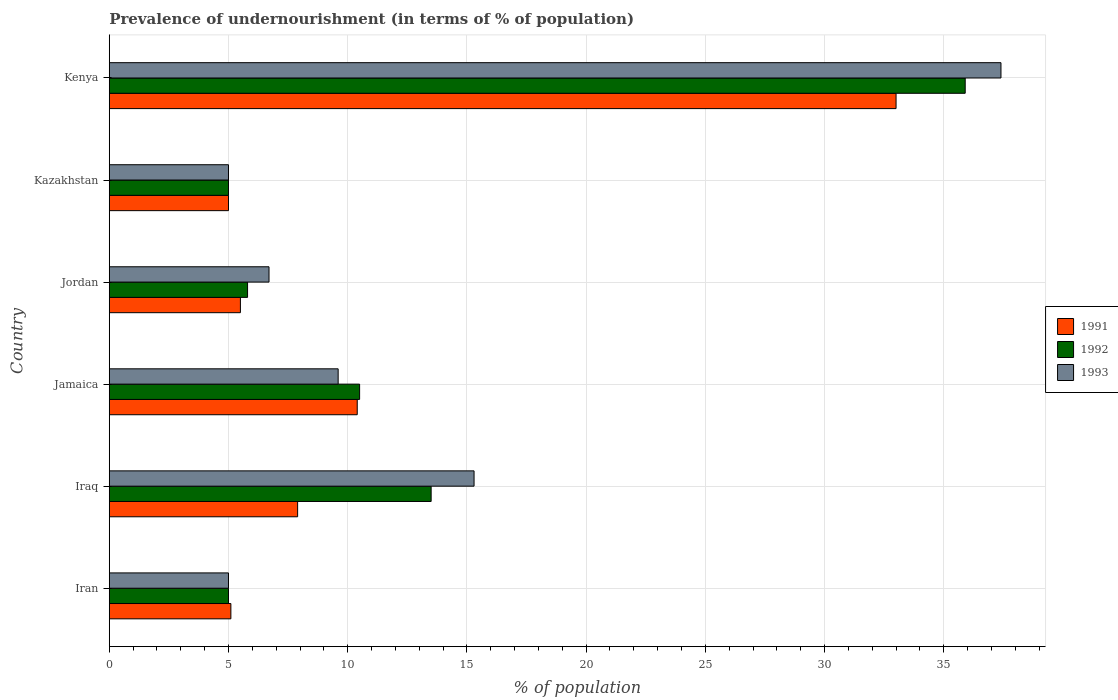How many different coloured bars are there?
Make the answer very short. 3. How many groups of bars are there?
Keep it short and to the point. 6. Are the number of bars per tick equal to the number of legend labels?
Your answer should be very brief. Yes. How many bars are there on the 1st tick from the bottom?
Your answer should be very brief. 3. What is the label of the 4th group of bars from the top?
Offer a very short reply. Jamaica. Across all countries, what is the maximum percentage of undernourished population in 1991?
Give a very brief answer. 33. Across all countries, what is the minimum percentage of undernourished population in 1992?
Your answer should be very brief. 5. In which country was the percentage of undernourished population in 1991 maximum?
Offer a very short reply. Kenya. In which country was the percentage of undernourished population in 1993 minimum?
Give a very brief answer. Iran. What is the total percentage of undernourished population in 1992 in the graph?
Give a very brief answer. 75.7. What is the difference between the percentage of undernourished population in 1993 in Jamaica and that in Jordan?
Offer a very short reply. 2.9. What is the difference between the percentage of undernourished population in 1991 in Iraq and the percentage of undernourished population in 1992 in Kenya?
Ensure brevity in your answer.  -28. What is the average percentage of undernourished population in 1993 per country?
Keep it short and to the point. 13.17. What is the difference between the percentage of undernourished population in 1992 and percentage of undernourished population in 1991 in Jamaica?
Provide a succinct answer. 0.1. In how many countries, is the percentage of undernourished population in 1991 greater than 30 %?
Your answer should be compact. 1. What is the ratio of the percentage of undernourished population in 1992 in Iran to that in Jamaica?
Keep it short and to the point. 0.48. Is the percentage of undernourished population in 1992 in Iraq less than that in Kenya?
Your answer should be very brief. Yes. Is the difference between the percentage of undernourished population in 1992 in Iran and Kazakhstan greater than the difference between the percentage of undernourished population in 1991 in Iran and Kazakhstan?
Offer a very short reply. No. What is the difference between the highest and the second highest percentage of undernourished population in 1992?
Offer a very short reply. 22.4. What is the difference between the highest and the lowest percentage of undernourished population in 1993?
Offer a terse response. 32.4. Is the sum of the percentage of undernourished population in 1992 in Iran and Kenya greater than the maximum percentage of undernourished population in 1991 across all countries?
Keep it short and to the point. Yes. What does the 1st bar from the top in Iraq represents?
Keep it short and to the point. 1993. What does the 3rd bar from the bottom in Jamaica represents?
Offer a very short reply. 1993. Is it the case that in every country, the sum of the percentage of undernourished population in 1992 and percentage of undernourished population in 1993 is greater than the percentage of undernourished population in 1991?
Provide a short and direct response. Yes. Are all the bars in the graph horizontal?
Your answer should be very brief. Yes. How many countries are there in the graph?
Ensure brevity in your answer.  6. Does the graph contain any zero values?
Provide a succinct answer. No. How many legend labels are there?
Give a very brief answer. 3. What is the title of the graph?
Make the answer very short. Prevalence of undernourishment (in terms of % of population). What is the label or title of the X-axis?
Provide a succinct answer. % of population. What is the label or title of the Y-axis?
Provide a succinct answer. Country. What is the % of population of 1992 in Iran?
Give a very brief answer. 5. What is the % of population of 1993 in Iran?
Your response must be concise. 5. What is the % of population in 1991 in Iraq?
Provide a succinct answer. 7.9. What is the % of population in 1992 in Iraq?
Your answer should be compact. 13.5. What is the % of population in 1993 in Iraq?
Ensure brevity in your answer.  15.3. What is the % of population in 1991 in Jamaica?
Offer a terse response. 10.4. What is the % of population of 1992 in Jamaica?
Keep it short and to the point. 10.5. What is the % of population of 1993 in Jamaica?
Give a very brief answer. 9.6. What is the % of population in 1992 in Jordan?
Keep it short and to the point. 5.8. What is the % of population of 1993 in Jordan?
Offer a very short reply. 6.7. What is the % of population of 1992 in Kenya?
Offer a terse response. 35.9. What is the % of population of 1993 in Kenya?
Give a very brief answer. 37.4. Across all countries, what is the maximum % of population of 1992?
Make the answer very short. 35.9. Across all countries, what is the maximum % of population in 1993?
Keep it short and to the point. 37.4. Across all countries, what is the minimum % of population in 1992?
Keep it short and to the point. 5. What is the total % of population of 1991 in the graph?
Ensure brevity in your answer.  66.9. What is the total % of population of 1992 in the graph?
Your answer should be compact. 75.7. What is the total % of population of 1993 in the graph?
Provide a short and direct response. 79. What is the difference between the % of population in 1992 in Iran and that in Iraq?
Offer a very short reply. -8.5. What is the difference between the % of population of 1993 in Iran and that in Iraq?
Your response must be concise. -10.3. What is the difference between the % of population of 1991 in Iran and that in Jamaica?
Your response must be concise. -5.3. What is the difference between the % of population of 1993 in Iran and that in Jamaica?
Provide a succinct answer. -4.6. What is the difference between the % of population in 1991 in Iran and that in Jordan?
Your answer should be compact. -0.4. What is the difference between the % of population in 1991 in Iran and that in Kazakhstan?
Your response must be concise. 0.1. What is the difference between the % of population of 1992 in Iran and that in Kazakhstan?
Offer a terse response. 0. What is the difference between the % of population in 1991 in Iran and that in Kenya?
Provide a succinct answer. -27.9. What is the difference between the % of population of 1992 in Iran and that in Kenya?
Provide a short and direct response. -30.9. What is the difference between the % of population of 1993 in Iran and that in Kenya?
Your response must be concise. -32.4. What is the difference between the % of population in 1993 in Iraq and that in Jamaica?
Your answer should be compact. 5.7. What is the difference between the % of population of 1993 in Iraq and that in Jordan?
Your answer should be compact. 8.6. What is the difference between the % of population in 1991 in Iraq and that in Kazakhstan?
Provide a short and direct response. 2.9. What is the difference between the % of population of 1992 in Iraq and that in Kazakhstan?
Keep it short and to the point. 8.5. What is the difference between the % of population of 1993 in Iraq and that in Kazakhstan?
Provide a succinct answer. 10.3. What is the difference between the % of population in 1991 in Iraq and that in Kenya?
Make the answer very short. -25.1. What is the difference between the % of population of 1992 in Iraq and that in Kenya?
Provide a succinct answer. -22.4. What is the difference between the % of population of 1993 in Iraq and that in Kenya?
Provide a succinct answer. -22.1. What is the difference between the % of population of 1991 in Jamaica and that in Jordan?
Your answer should be compact. 4.9. What is the difference between the % of population in 1992 in Jamaica and that in Jordan?
Give a very brief answer. 4.7. What is the difference between the % of population in 1993 in Jamaica and that in Jordan?
Keep it short and to the point. 2.9. What is the difference between the % of population in 1993 in Jamaica and that in Kazakhstan?
Make the answer very short. 4.6. What is the difference between the % of population in 1991 in Jamaica and that in Kenya?
Provide a short and direct response. -22.6. What is the difference between the % of population in 1992 in Jamaica and that in Kenya?
Your answer should be compact. -25.4. What is the difference between the % of population in 1993 in Jamaica and that in Kenya?
Offer a very short reply. -27.8. What is the difference between the % of population in 1991 in Jordan and that in Kenya?
Ensure brevity in your answer.  -27.5. What is the difference between the % of population in 1992 in Jordan and that in Kenya?
Keep it short and to the point. -30.1. What is the difference between the % of population in 1993 in Jordan and that in Kenya?
Provide a short and direct response. -30.7. What is the difference between the % of population of 1992 in Kazakhstan and that in Kenya?
Your response must be concise. -30.9. What is the difference between the % of population of 1993 in Kazakhstan and that in Kenya?
Make the answer very short. -32.4. What is the difference between the % of population in 1991 in Iran and the % of population in 1993 in Jamaica?
Provide a short and direct response. -4.5. What is the difference between the % of population of 1992 in Iran and the % of population of 1993 in Jamaica?
Offer a very short reply. -4.6. What is the difference between the % of population of 1992 in Iran and the % of population of 1993 in Jordan?
Ensure brevity in your answer.  -1.7. What is the difference between the % of population in 1991 in Iran and the % of population in 1992 in Kazakhstan?
Your answer should be compact. 0.1. What is the difference between the % of population of 1991 in Iran and the % of population of 1992 in Kenya?
Provide a succinct answer. -30.8. What is the difference between the % of population in 1991 in Iran and the % of population in 1993 in Kenya?
Your answer should be very brief. -32.3. What is the difference between the % of population in 1992 in Iran and the % of population in 1993 in Kenya?
Your answer should be compact. -32.4. What is the difference between the % of population in 1991 in Iraq and the % of population in 1992 in Jordan?
Give a very brief answer. 2.1. What is the difference between the % of population in 1992 in Iraq and the % of population in 1993 in Kazakhstan?
Your answer should be very brief. 8.5. What is the difference between the % of population of 1991 in Iraq and the % of population of 1993 in Kenya?
Your answer should be compact. -29.5. What is the difference between the % of population of 1992 in Iraq and the % of population of 1993 in Kenya?
Offer a very short reply. -23.9. What is the difference between the % of population of 1991 in Jamaica and the % of population of 1992 in Jordan?
Offer a very short reply. 4.6. What is the difference between the % of population of 1991 in Jamaica and the % of population of 1992 in Kazakhstan?
Offer a terse response. 5.4. What is the difference between the % of population of 1991 in Jamaica and the % of population of 1993 in Kazakhstan?
Your answer should be compact. 5.4. What is the difference between the % of population of 1992 in Jamaica and the % of population of 1993 in Kazakhstan?
Keep it short and to the point. 5.5. What is the difference between the % of population in 1991 in Jamaica and the % of population in 1992 in Kenya?
Your answer should be compact. -25.5. What is the difference between the % of population of 1991 in Jamaica and the % of population of 1993 in Kenya?
Your answer should be compact. -27. What is the difference between the % of population in 1992 in Jamaica and the % of population in 1993 in Kenya?
Provide a succinct answer. -26.9. What is the difference between the % of population of 1991 in Jordan and the % of population of 1992 in Kazakhstan?
Provide a succinct answer. 0.5. What is the difference between the % of population of 1991 in Jordan and the % of population of 1993 in Kazakhstan?
Offer a terse response. 0.5. What is the difference between the % of population of 1992 in Jordan and the % of population of 1993 in Kazakhstan?
Offer a terse response. 0.8. What is the difference between the % of population of 1991 in Jordan and the % of population of 1992 in Kenya?
Provide a succinct answer. -30.4. What is the difference between the % of population in 1991 in Jordan and the % of population in 1993 in Kenya?
Give a very brief answer. -31.9. What is the difference between the % of population in 1992 in Jordan and the % of population in 1993 in Kenya?
Offer a terse response. -31.6. What is the difference between the % of population in 1991 in Kazakhstan and the % of population in 1992 in Kenya?
Give a very brief answer. -30.9. What is the difference between the % of population in 1991 in Kazakhstan and the % of population in 1993 in Kenya?
Provide a short and direct response. -32.4. What is the difference between the % of population of 1992 in Kazakhstan and the % of population of 1993 in Kenya?
Provide a succinct answer. -32.4. What is the average % of population of 1991 per country?
Ensure brevity in your answer.  11.15. What is the average % of population in 1992 per country?
Give a very brief answer. 12.62. What is the average % of population in 1993 per country?
Your answer should be very brief. 13.17. What is the difference between the % of population of 1991 and % of population of 1993 in Iran?
Offer a terse response. 0.1. What is the difference between the % of population in 1991 and % of population in 1993 in Jamaica?
Offer a very short reply. 0.8. What is the difference between the % of population in 1992 and % of population in 1993 in Jamaica?
Offer a terse response. 0.9. What is the difference between the % of population of 1991 and % of population of 1993 in Jordan?
Your answer should be compact. -1.2. What is the ratio of the % of population of 1991 in Iran to that in Iraq?
Offer a terse response. 0.65. What is the ratio of the % of population in 1992 in Iran to that in Iraq?
Provide a short and direct response. 0.37. What is the ratio of the % of population of 1993 in Iran to that in Iraq?
Offer a terse response. 0.33. What is the ratio of the % of population in 1991 in Iran to that in Jamaica?
Give a very brief answer. 0.49. What is the ratio of the % of population in 1992 in Iran to that in Jamaica?
Keep it short and to the point. 0.48. What is the ratio of the % of population of 1993 in Iran to that in Jamaica?
Your answer should be very brief. 0.52. What is the ratio of the % of population in 1991 in Iran to that in Jordan?
Make the answer very short. 0.93. What is the ratio of the % of population of 1992 in Iran to that in Jordan?
Provide a succinct answer. 0.86. What is the ratio of the % of population of 1993 in Iran to that in Jordan?
Provide a succinct answer. 0.75. What is the ratio of the % of population in 1991 in Iran to that in Kazakhstan?
Offer a very short reply. 1.02. What is the ratio of the % of population of 1992 in Iran to that in Kazakhstan?
Keep it short and to the point. 1. What is the ratio of the % of population in 1993 in Iran to that in Kazakhstan?
Your answer should be very brief. 1. What is the ratio of the % of population of 1991 in Iran to that in Kenya?
Provide a short and direct response. 0.15. What is the ratio of the % of population in 1992 in Iran to that in Kenya?
Provide a succinct answer. 0.14. What is the ratio of the % of population in 1993 in Iran to that in Kenya?
Make the answer very short. 0.13. What is the ratio of the % of population in 1991 in Iraq to that in Jamaica?
Ensure brevity in your answer.  0.76. What is the ratio of the % of population in 1992 in Iraq to that in Jamaica?
Keep it short and to the point. 1.29. What is the ratio of the % of population in 1993 in Iraq to that in Jamaica?
Provide a short and direct response. 1.59. What is the ratio of the % of population of 1991 in Iraq to that in Jordan?
Your response must be concise. 1.44. What is the ratio of the % of population in 1992 in Iraq to that in Jordan?
Provide a succinct answer. 2.33. What is the ratio of the % of population in 1993 in Iraq to that in Jordan?
Offer a terse response. 2.28. What is the ratio of the % of population in 1991 in Iraq to that in Kazakhstan?
Your response must be concise. 1.58. What is the ratio of the % of population in 1993 in Iraq to that in Kazakhstan?
Provide a succinct answer. 3.06. What is the ratio of the % of population of 1991 in Iraq to that in Kenya?
Ensure brevity in your answer.  0.24. What is the ratio of the % of population in 1992 in Iraq to that in Kenya?
Offer a very short reply. 0.38. What is the ratio of the % of population of 1993 in Iraq to that in Kenya?
Make the answer very short. 0.41. What is the ratio of the % of population of 1991 in Jamaica to that in Jordan?
Ensure brevity in your answer.  1.89. What is the ratio of the % of population in 1992 in Jamaica to that in Jordan?
Give a very brief answer. 1.81. What is the ratio of the % of population in 1993 in Jamaica to that in Jordan?
Ensure brevity in your answer.  1.43. What is the ratio of the % of population in 1991 in Jamaica to that in Kazakhstan?
Make the answer very short. 2.08. What is the ratio of the % of population of 1992 in Jamaica to that in Kazakhstan?
Ensure brevity in your answer.  2.1. What is the ratio of the % of population in 1993 in Jamaica to that in Kazakhstan?
Provide a short and direct response. 1.92. What is the ratio of the % of population of 1991 in Jamaica to that in Kenya?
Your answer should be very brief. 0.32. What is the ratio of the % of population of 1992 in Jamaica to that in Kenya?
Keep it short and to the point. 0.29. What is the ratio of the % of population in 1993 in Jamaica to that in Kenya?
Keep it short and to the point. 0.26. What is the ratio of the % of population of 1991 in Jordan to that in Kazakhstan?
Provide a short and direct response. 1.1. What is the ratio of the % of population in 1992 in Jordan to that in Kazakhstan?
Provide a short and direct response. 1.16. What is the ratio of the % of population in 1993 in Jordan to that in Kazakhstan?
Offer a terse response. 1.34. What is the ratio of the % of population of 1991 in Jordan to that in Kenya?
Provide a succinct answer. 0.17. What is the ratio of the % of population in 1992 in Jordan to that in Kenya?
Offer a very short reply. 0.16. What is the ratio of the % of population of 1993 in Jordan to that in Kenya?
Offer a terse response. 0.18. What is the ratio of the % of population of 1991 in Kazakhstan to that in Kenya?
Your answer should be compact. 0.15. What is the ratio of the % of population of 1992 in Kazakhstan to that in Kenya?
Offer a terse response. 0.14. What is the ratio of the % of population of 1993 in Kazakhstan to that in Kenya?
Your answer should be very brief. 0.13. What is the difference between the highest and the second highest % of population in 1991?
Make the answer very short. 22.6. What is the difference between the highest and the second highest % of population of 1992?
Offer a terse response. 22.4. What is the difference between the highest and the second highest % of population of 1993?
Provide a succinct answer. 22.1. What is the difference between the highest and the lowest % of population of 1992?
Your response must be concise. 30.9. What is the difference between the highest and the lowest % of population of 1993?
Ensure brevity in your answer.  32.4. 